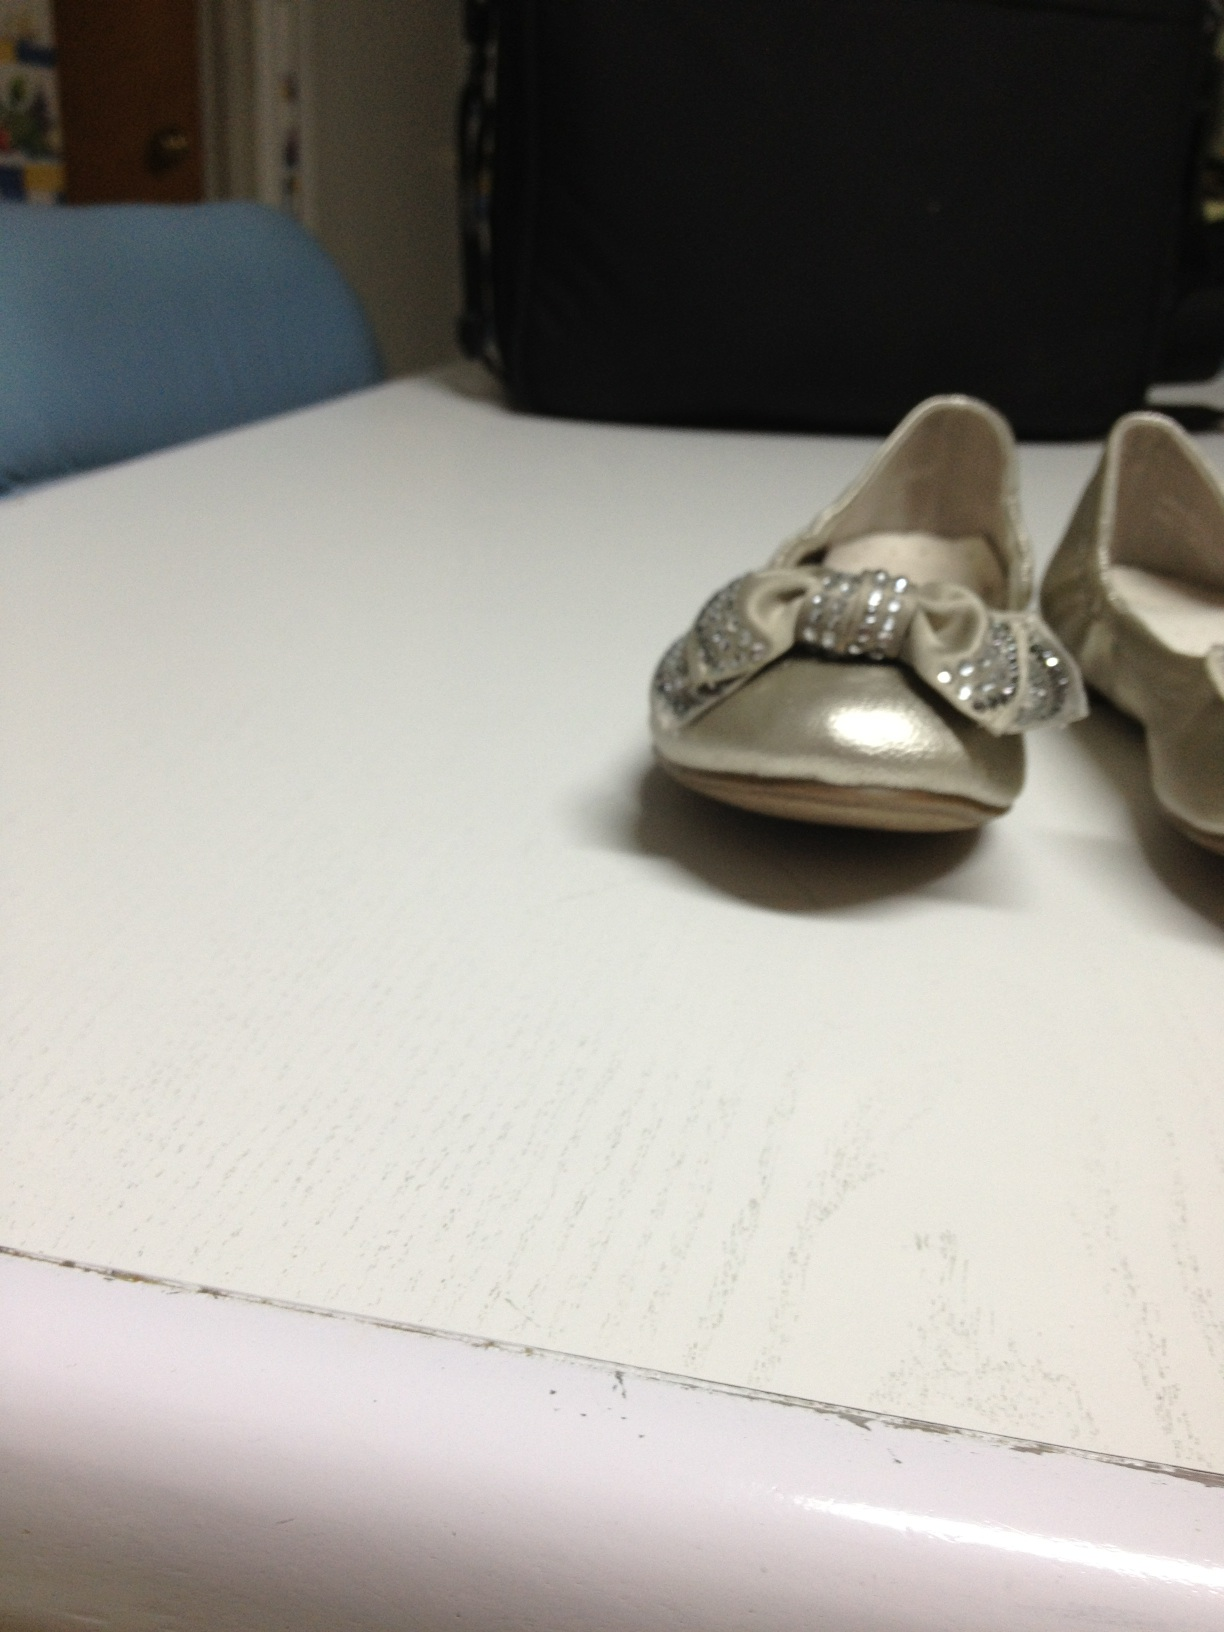Invent a wild and imaginative story involving these shoes. In a parallel universe where shoes have magical powers, these silver shoes with sparkling bows were no ordinary footwear. They belonged to a secret society of guardians who protected the balance between the realms of imagination and reality. One day, these shoes chose a new guardian, a young girl named Luna. With every step Luna took in these shoes, she could transcend dimensions, communicate with imaginary creatures, and restore harmony where chaos reigned. Luna embarked on incredible adventures, from taming wild dragons in the skies to calming raging seas, her silver shoes shimmering with every stride, illuminating the path of the guardian's destiny. 